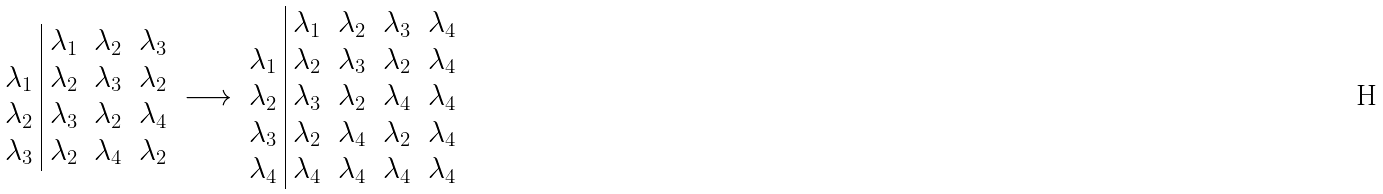Convert formula to latex. <formula><loc_0><loc_0><loc_500><loc_500>\begin{array} { c | c c c } & \lambda _ { 1 } & \lambda _ { 2 } & \lambda _ { 3 } \\ \lambda _ { 1 } & \lambda _ { 2 } & \lambda _ { 3 } & \lambda _ { 2 } \\ \lambda _ { 2 } & \lambda _ { 3 } & \lambda _ { 2 } & \lambda _ { 4 } \\ \lambda _ { 3 } & \lambda _ { 2 } & \lambda _ { 4 } & \lambda _ { 2 } \end{array} \longrightarrow \begin{array} { c | c c c c } & \lambda _ { 1 } & \lambda _ { 2 } & \lambda _ { 3 } & \lambda _ { 4 } \\ \lambda _ { 1 } & \lambda _ { 2 } & \lambda _ { 3 } & \lambda _ { 2 } & \lambda _ { 4 } \\ \lambda _ { 2 } & \lambda _ { 3 } & \lambda _ { 2 } & \lambda _ { 4 } & \lambda _ { 4 } \\ \lambda _ { 3 } & \lambda _ { 2 } & \lambda _ { 4 } & \lambda _ { 2 } & \lambda _ { 4 } \\ \lambda _ { 4 } & \lambda _ { 4 } & \lambda _ { 4 } & \lambda _ { 4 } & \lambda _ { 4 } \end{array}</formula> 